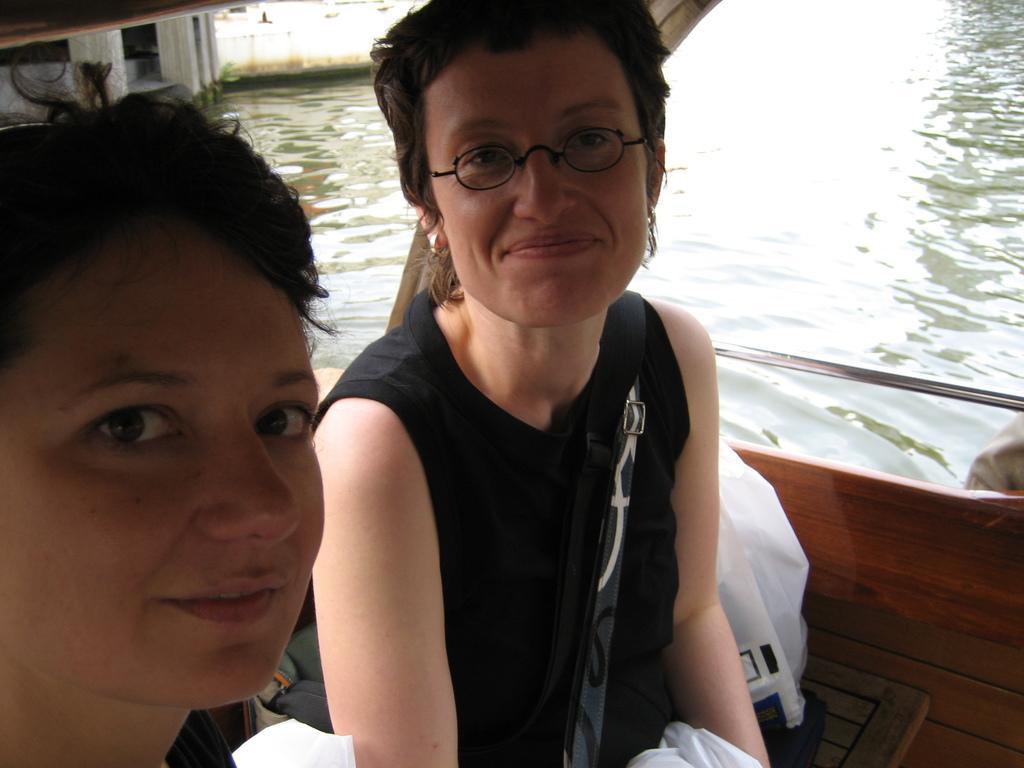Please provide a concise description of this image. In this image we can see two persons are sitting in a boat and smiling, there is the water. 